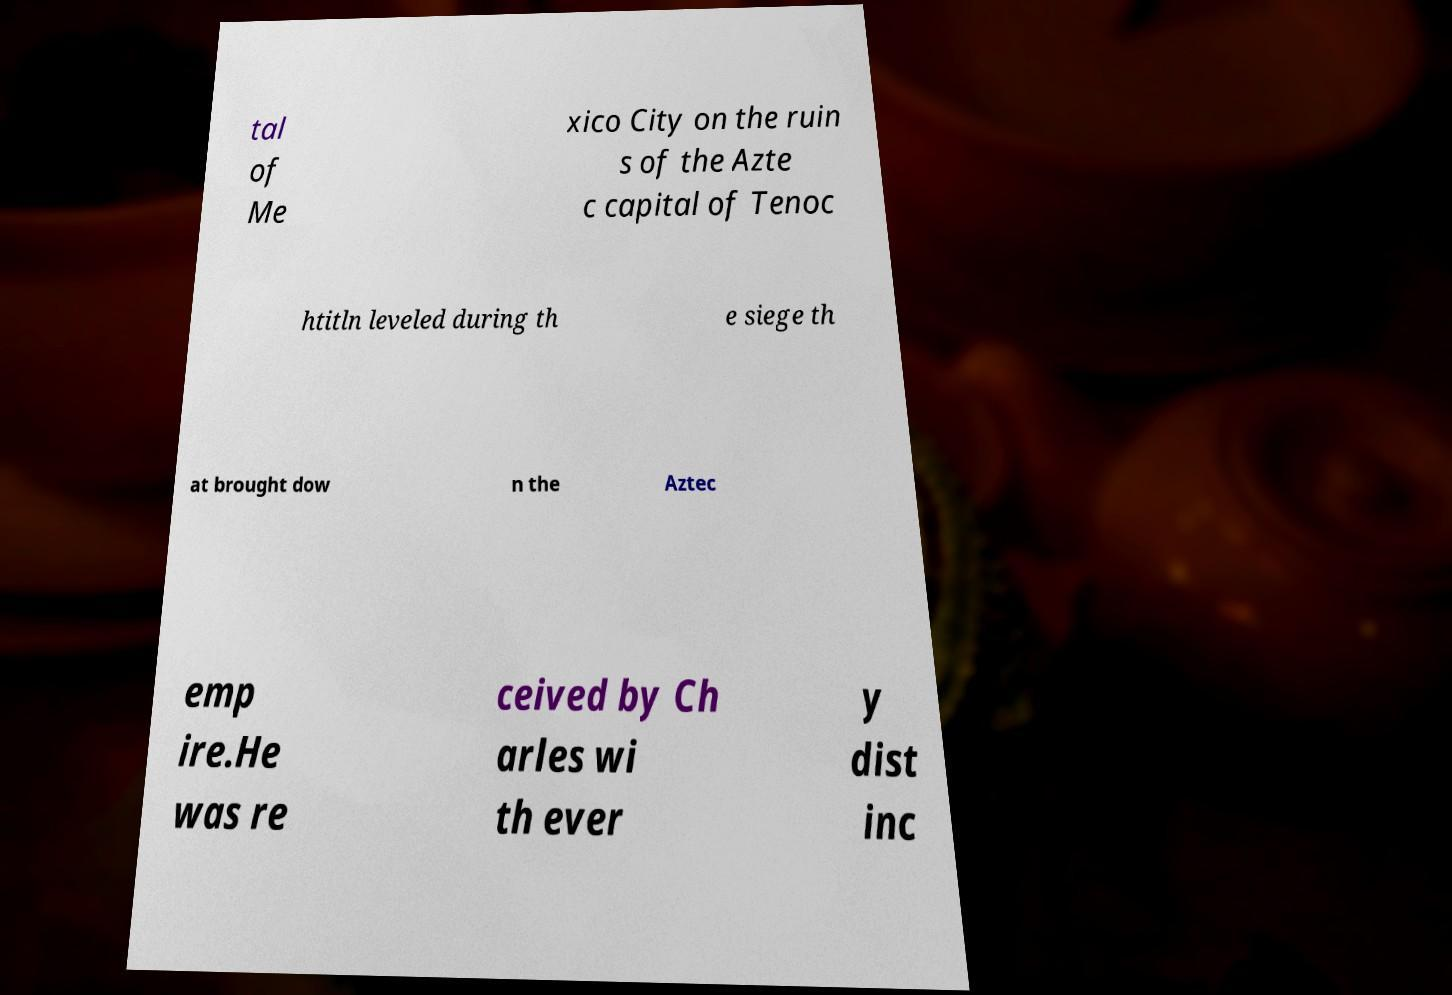Can you accurately transcribe the text from the provided image for me? tal of Me xico City on the ruin s of the Azte c capital of Tenoc htitln leveled during th e siege th at brought dow n the Aztec emp ire.He was re ceived by Ch arles wi th ever y dist inc 